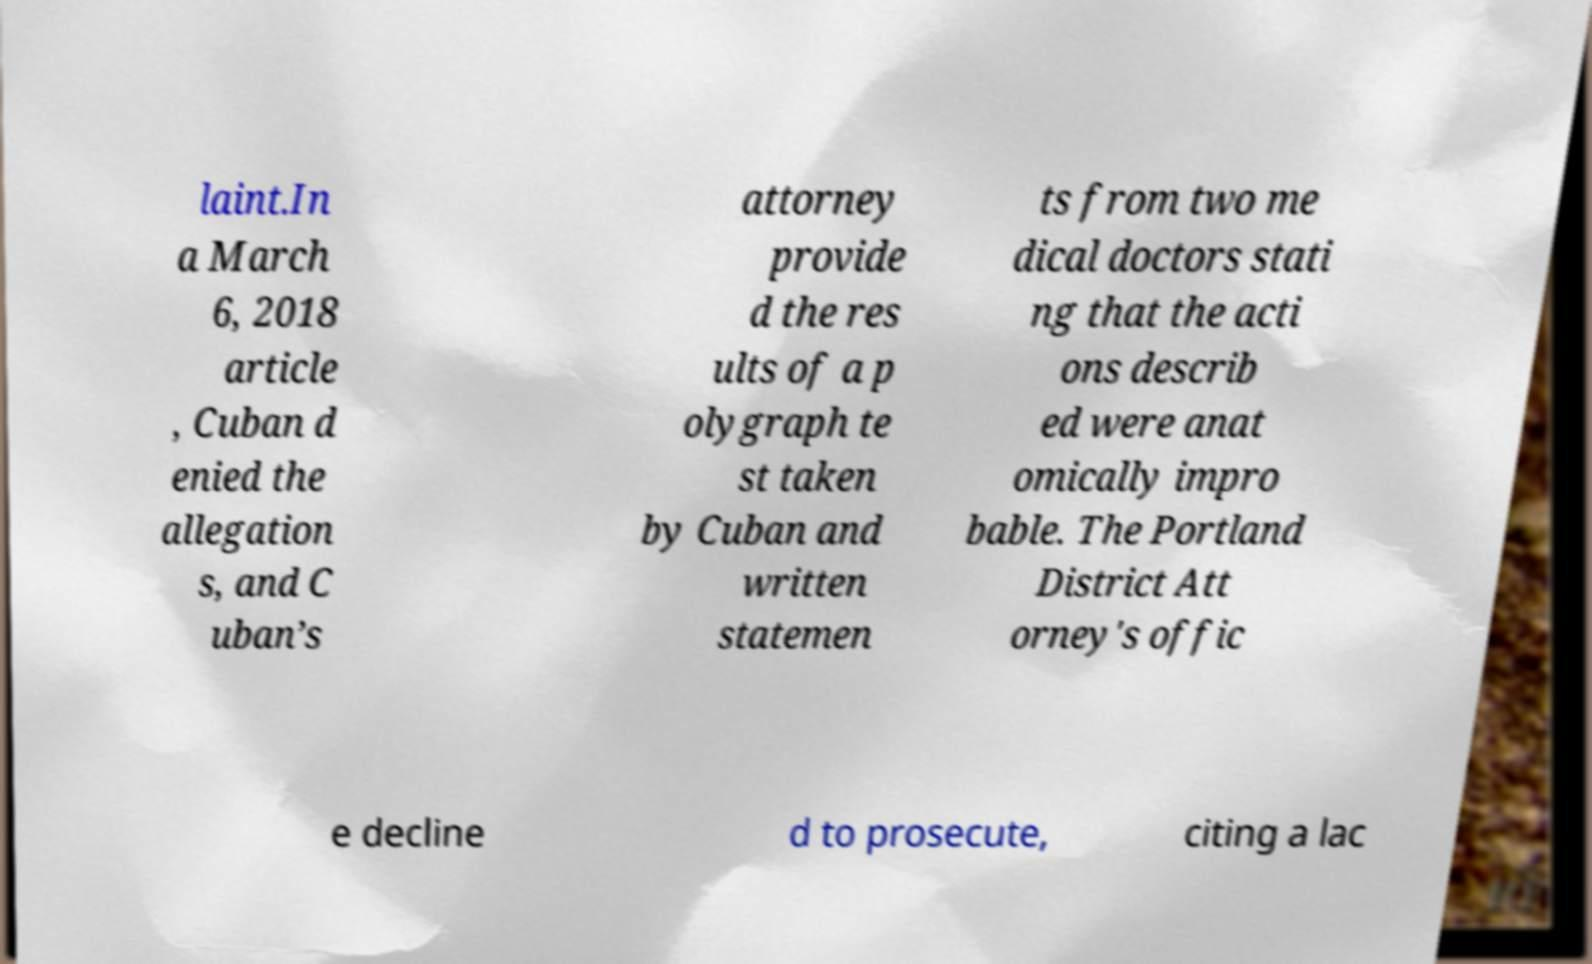Could you assist in decoding the text presented in this image and type it out clearly? laint.In a March 6, 2018 article , Cuban d enied the allegation s, and C uban’s attorney provide d the res ults of a p olygraph te st taken by Cuban and written statemen ts from two me dical doctors stati ng that the acti ons describ ed were anat omically impro bable. The Portland District Att orney's offic e decline d to prosecute, citing a lac 